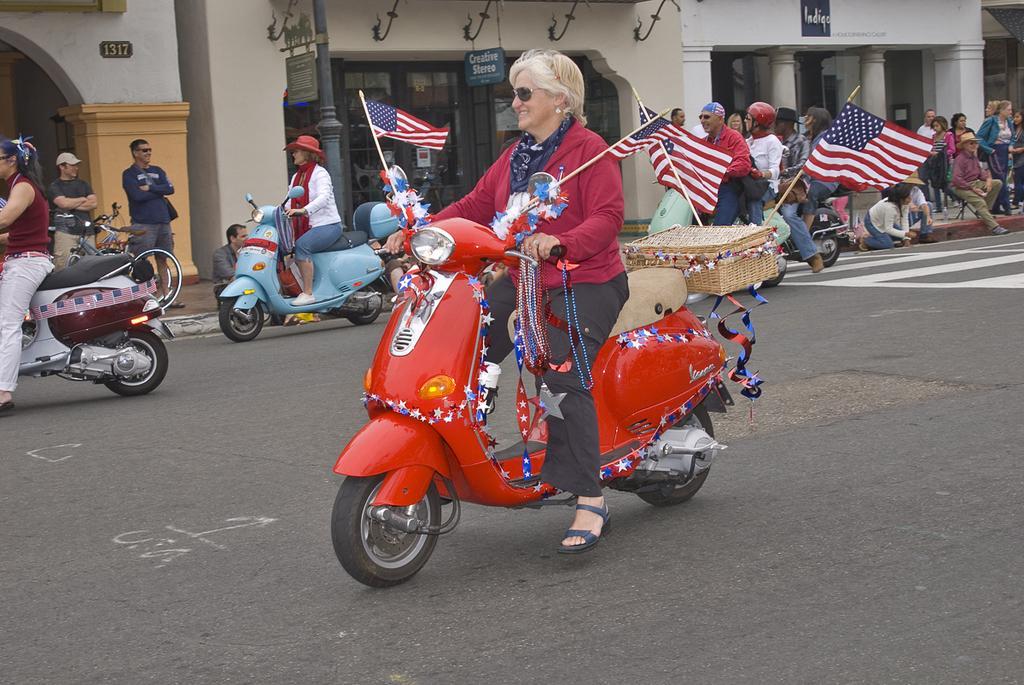Could you give a brief overview of what you see in this image? In this image i can see group of people some are riding the scooter by holding the flags on the road few people are standing on the footpath at the back ground i can see a store, a building and a board. 